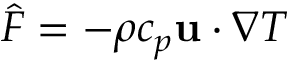<formula> <loc_0><loc_0><loc_500><loc_500>\widehat { F } = - \rho { c _ { p } } { u } \cdot \nabla T</formula> 